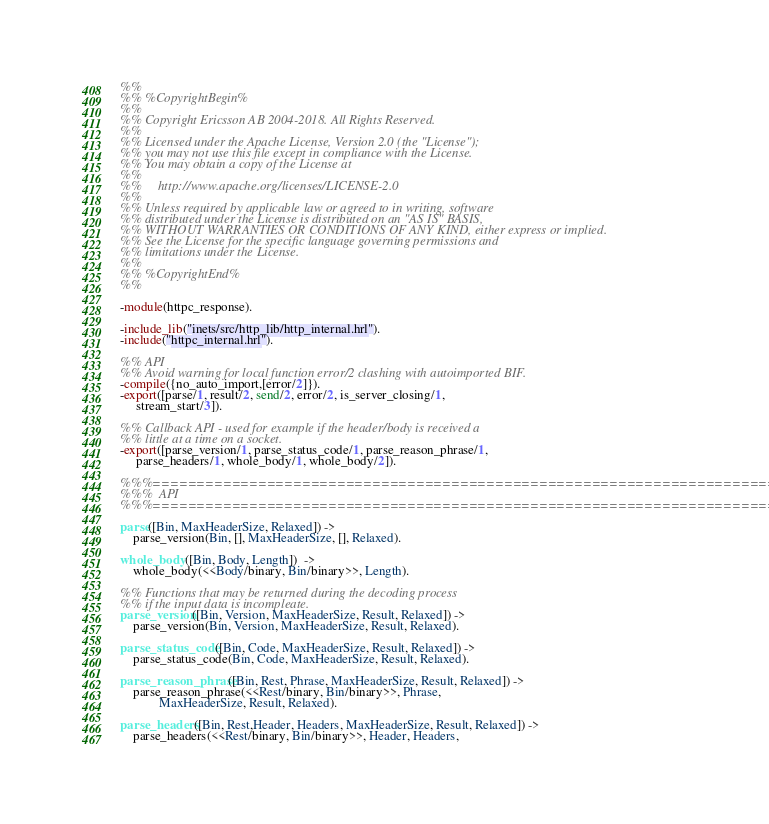<code> <loc_0><loc_0><loc_500><loc_500><_Erlang_>%%
%% %CopyrightBegin%
%%
%% Copyright Ericsson AB 2004-2018. All Rights Reserved.
%%
%% Licensed under the Apache License, Version 2.0 (the "License");
%% you may not use this file except in compliance with the License.
%% You may obtain a copy of the License at
%%
%%     http://www.apache.org/licenses/LICENSE-2.0
%%
%% Unless required by applicable law or agreed to in writing, software
%% distributed under the License is distributed on an "AS IS" BASIS,
%% WITHOUT WARRANTIES OR CONDITIONS OF ANY KIND, either express or implied.
%% See the License for the specific language governing permissions and
%% limitations under the License.
%%
%% %CopyrightEnd%
%%

-module(httpc_response).

-include_lib("inets/src/http_lib/http_internal.hrl").
-include("httpc_internal.hrl").

%% API
%% Avoid warning for local function error/2 clashing with autoimported BIF.
-compile({no_auto_import,[error/2]}).
-export([parse/1, result/2, send/2, error/2, is_server_closing/1, 
	 stream_start/3]).

%% Callback API - used for example if the header/body is received a
%% little at a time on a socket. 
-export([parse_version/1, parse_status_code/1, parse_reason_phrase/1,
	 parse_headers/1, whole_body/1, whole_body/2]).

%%%=========================================================================
%%%  API
%%%=========================================================================

parse([Bin, MaxHeaderSize, Relaxed]) ->
    parse_version(Bin, [], MaxHeaderSize, [], Relaxed).

whole_body([Bin, Body, Length])  ->
    whole_body(<<Body/binary, Bin/binary>>, Length).

%% Functions that may be returned during the decoding process
%% if the input data is incompleate. 
parse_version([Bin, Version, MaxHeaderSize, Result, Relaxed]) ->
    parse_version(Bin, Version, MaxHeaderSize, Result, Relaxed).

parse_status_code([Bin, Code, MaxHeaderSize, Result, Relaxed]) ->
    parse_status_code(Bin, Code, MaxHeaderSize, Result, Relaxed).

parse_reason_phrase([Bin, Rest, Phrase, MaxHeaderSize, Result, Relaxed]) ->
    parse_reason_phrase(<<Rest/binary, Bin/binary>>, Phrase, 
			MaxHeaderSize, Result, Relaxed).

parse_headers([Bin, Rest,Header, Headers, MaxHeaderSize, Result, Relaxed]) ->
    parse_headers(<<Rest/binary, Bin/binary>>, Header, Headers, </code> 